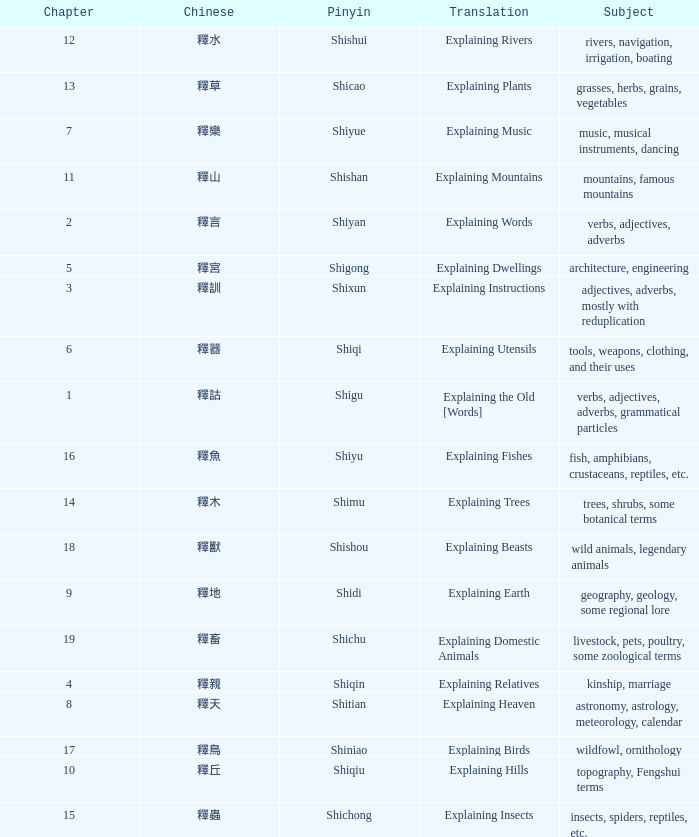Name the chapter with chinese of 釋水 12.0. 